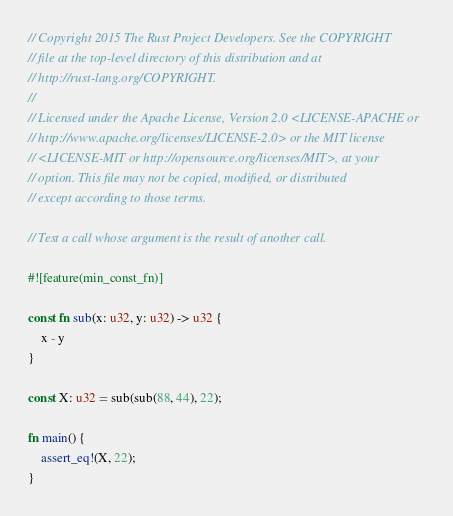<code> <loc_0><loc_0><loc_500><loc_500><_Rust_>// Copyright 2015 The Rust Project Developers. See the COPYRIGHT
// file at the top-level directory of this distribution and at
// http://rust-lang.org/COPYRIGHT.
//
// Licensed under the Apache License, Version 2.0 <LICENSE-APACHE or
// http://www.apache.org/licenses/LICENSE-2.0> or the MIT license
// <LICENSE-MIT or http://opensource.org/licenses/MIT>, at your
// option. This file may not be copied, modified, or distributed
// except according to those terms.

// Test a call whose argument is the result of another call.

#![feature(min_const_fn)]

const fn sub(x: u32, y: u32) -> u32 {
    x - y
}

const X: u32 = sub(sub(88, 44), 22);

fn main() {
    assert_eq!(X, 22);
}
</code> 